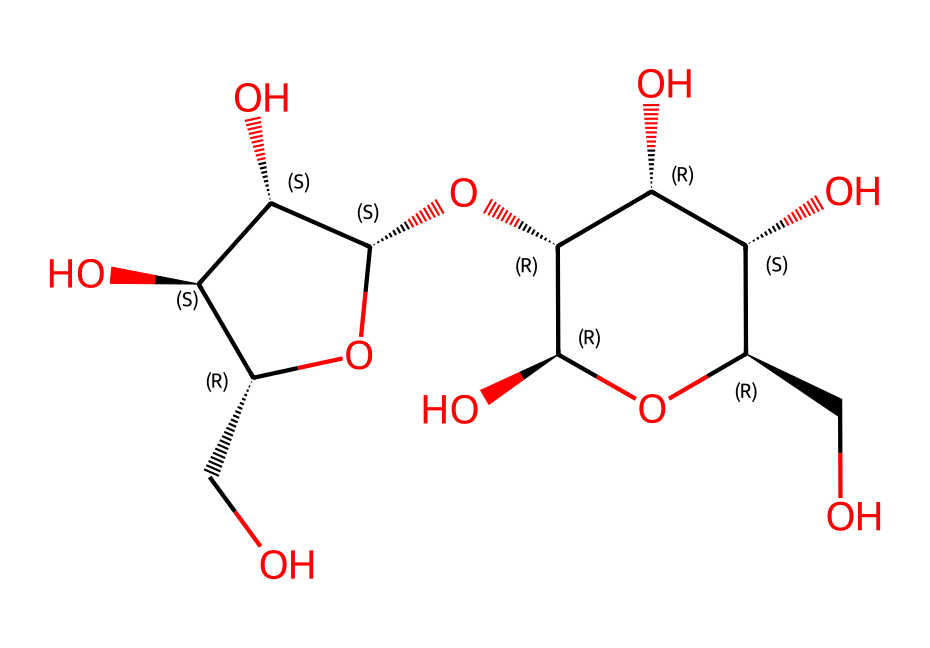What is the molecular formula of this chemical? To determine the molecular formula, count the number of each type of atom represented in the SMILES string. In the given SMILES, we have 6 carbon atoms (C), 10 hydrogen atoms (H), and 5 oxygen atoms (O). Thus, the molecular formula is computed as C6H10O5.
Answer: C6H10O5 How many rings are present in this structure? The SMILES shows a cyclic structure as indicated by the '1' and '2' which denote ring closures. Examining the structure shows one ring (the number '1' indicates closure), thus only one ring is present in this compound.
Answer: 1 What type of glycosidic linkages can be inferred from this structure? This compound features multiple hydroxyl groups (OH) and has a structure resembling cellulose, which typically includes β(1→4) glycosidic linkages. The presence of multiple interconnected units suggests these linkages, common in polysaccharides such as cellulose.
Answer: β(1→4) Is this chemical a monosaccharide, disaccharide, or polysaccharide? By analyzing the structure, it consists of multiple monosaccharide units linked together, which classifies it as a polysaccharide. The repeating units and complex structure indicate that it is not a single monosaccharide or a disaccharide.
Answer: polysaccharide What functional groups are present in this structure? The presence of multiple hydroxyl groups (OH) can be identified throughout the structure as indicated in the SMILES. These functional groups contribute to the solubility and reactivity of the molecule, characteristic of carbohydrates like cellulose.
Answer: hydroxyl groups 